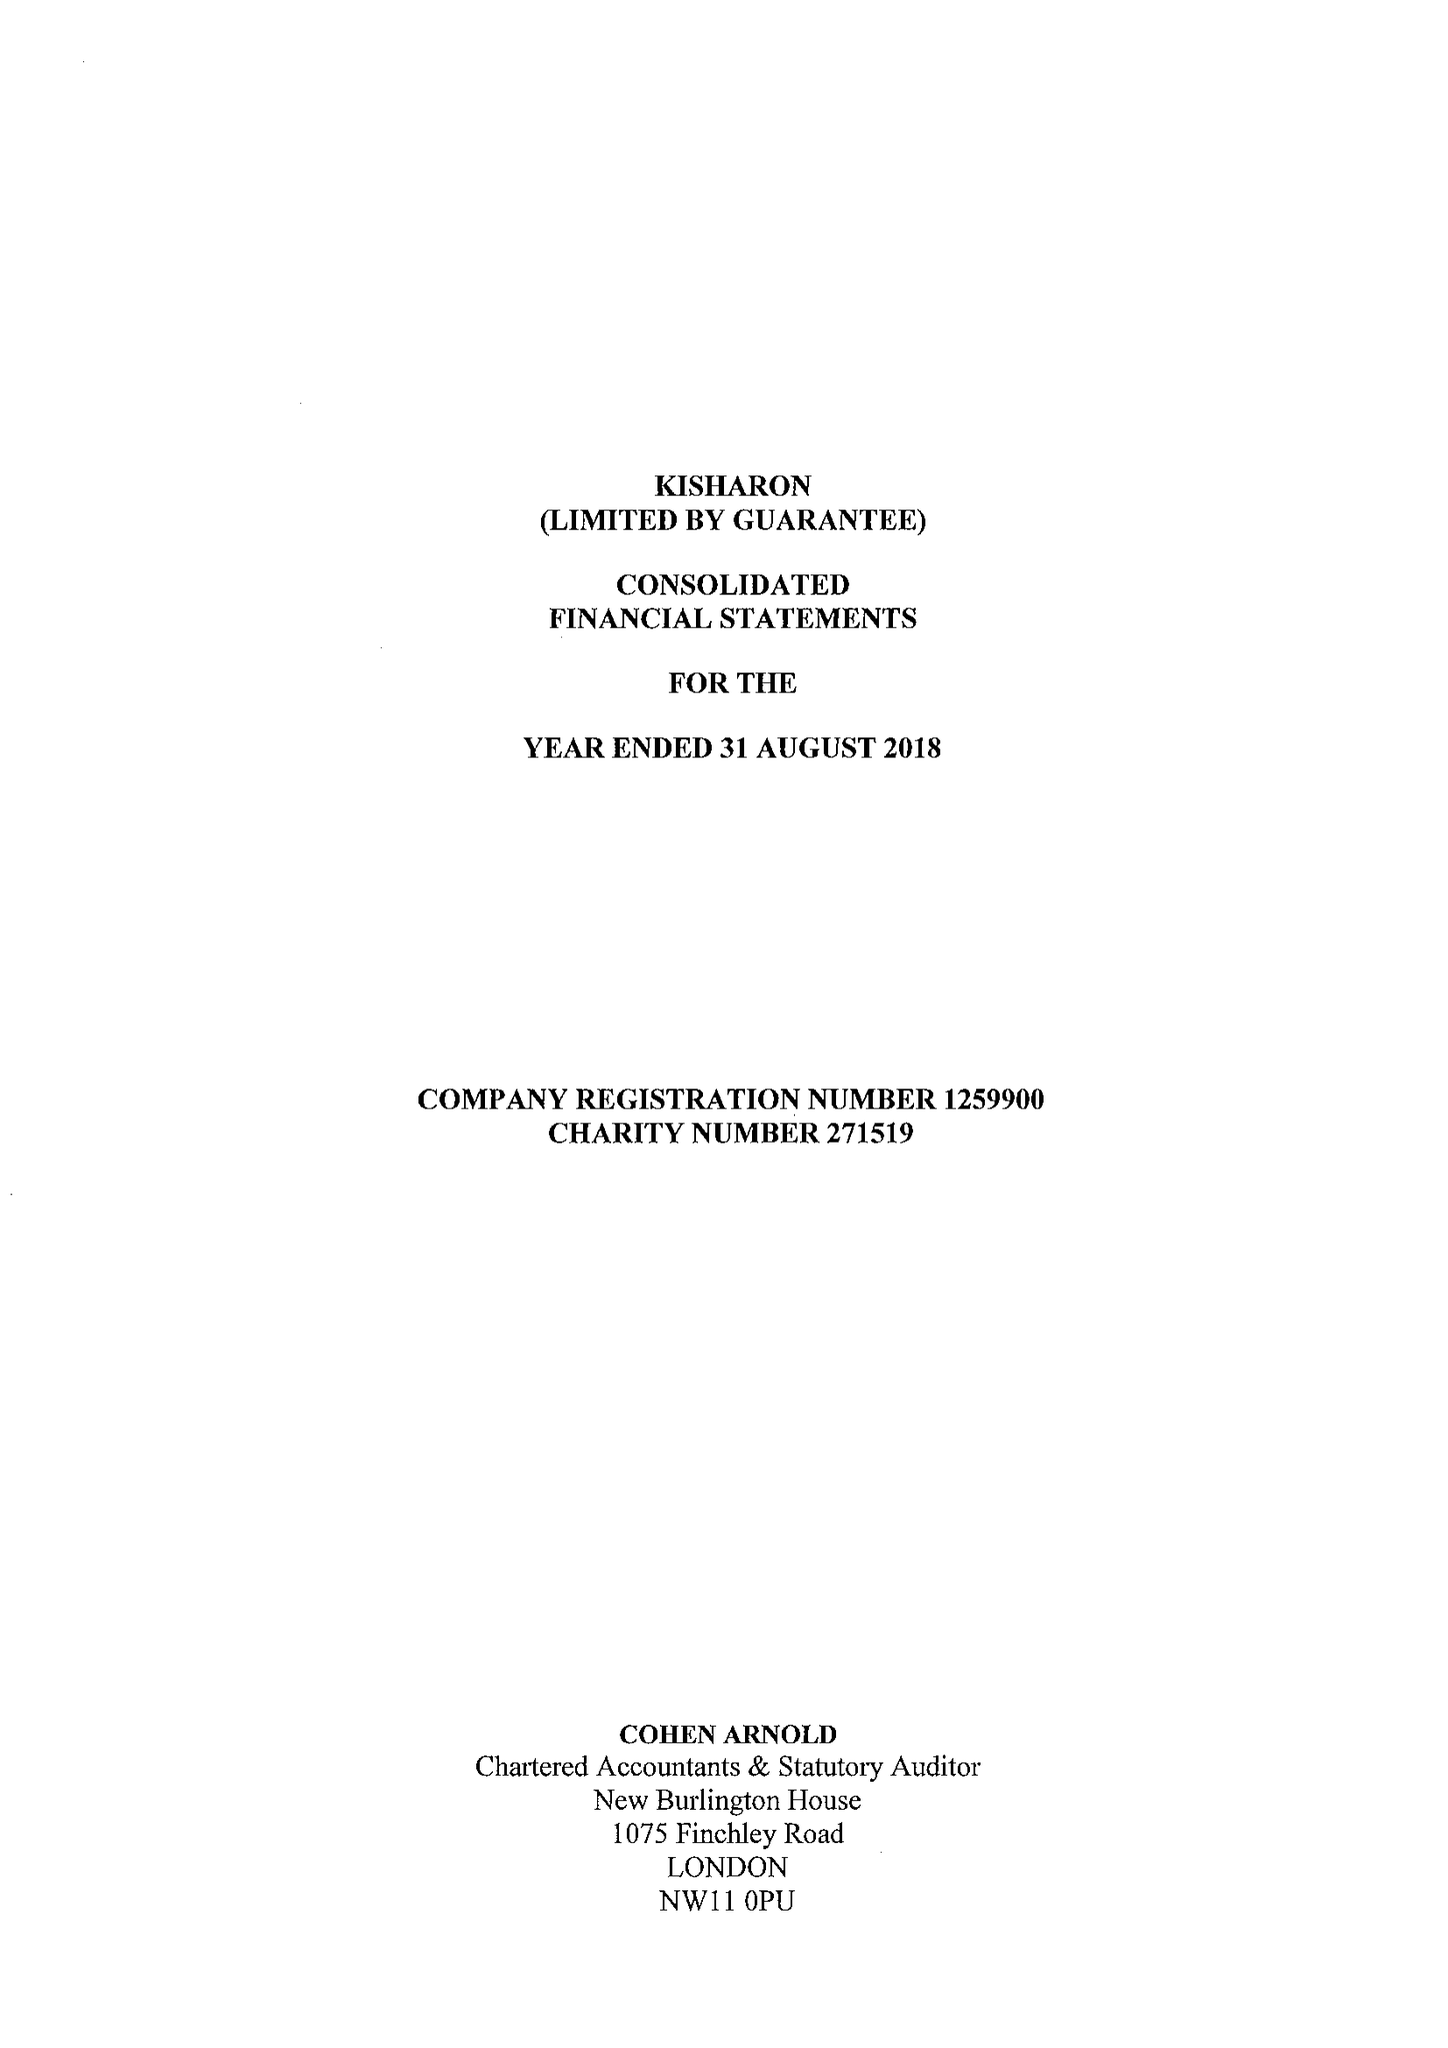What is the value for the charity_number?
Answer the question using a single word or phrase. 271519 